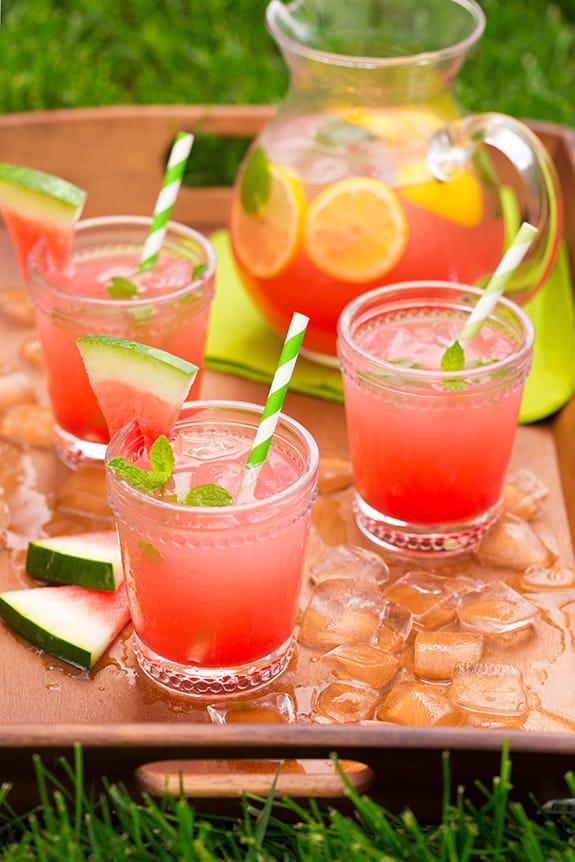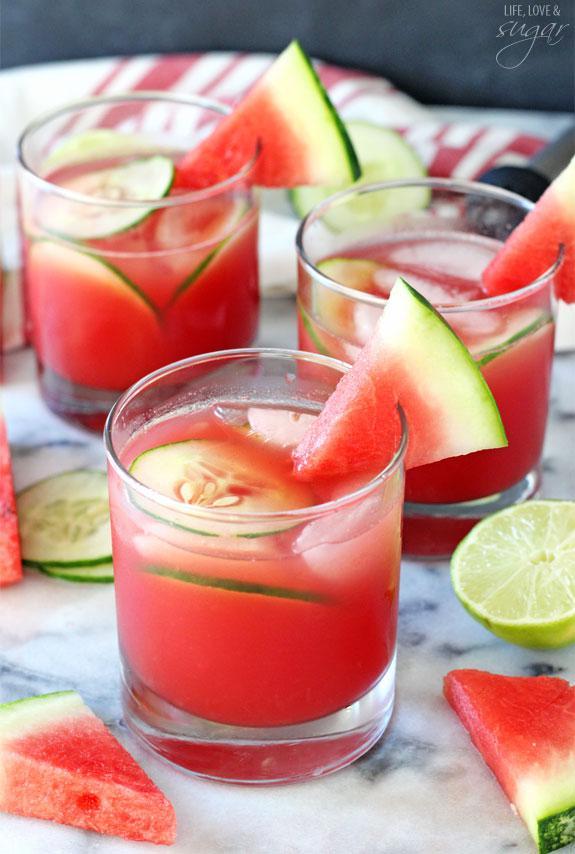The first image is the image on the left, the second image is the image on the right. For the images displayed, is the sentence "Left and right images show the same number of prepared drinks in serving cups." factually correct? Answer yes or no. Yes. The first image is the image on the left, the second image is the image on the right. Evaluate the accuracy of this statement regarding the images: "There is more than one slice of lemon in the image on the left". Is it true? Answer yes or no. Yes. 